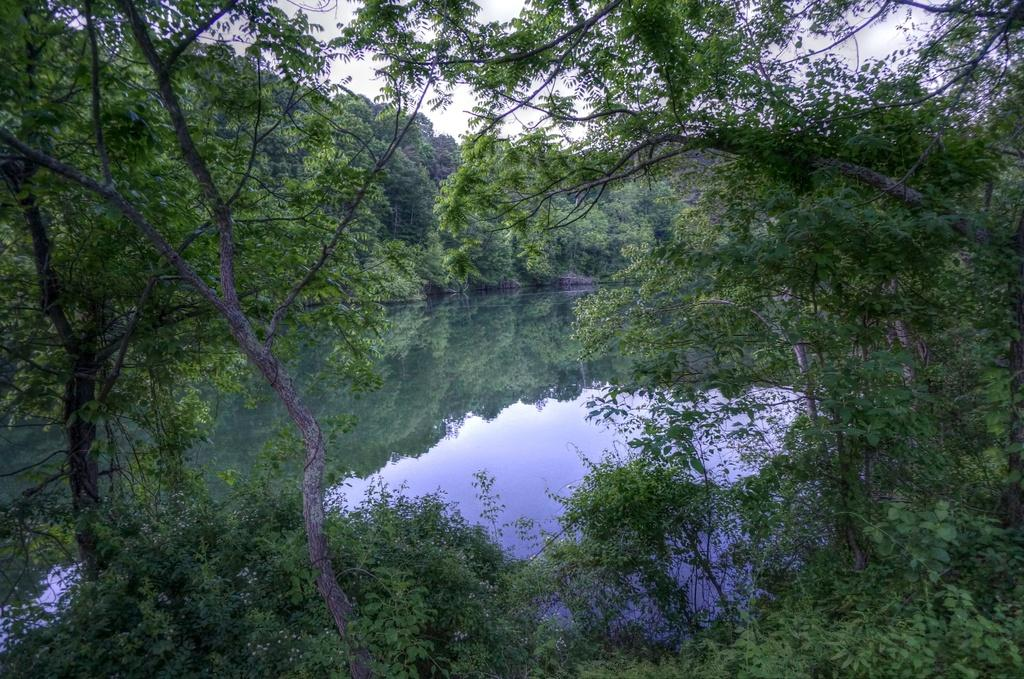What type of vegetation can be seen in the image? There are plants and trees visible in the image. What is the primary element in the image? Water is the primary element visible in the image. What can be seen in the sky in the image? The sky is visible in the image. How does the water in the image interact with the surrounding environment? The water in the image reflects the trees and sky. What flavor of cave can be seen in the image? There is no cave present in the image, and therefore no flavor can be associated with it. Are there any bears visible in the image? There are no bears present in the image. 